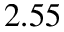<formula> <loc_0><loc_0><loc_500><loc_500>2 . 5 5</formula> 